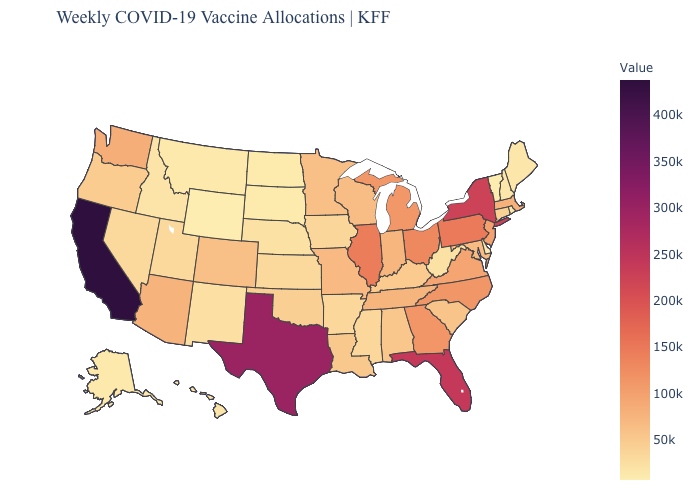Is the legend a continuous bar?
Short answer required. Yes. Does Alaska have the highest value in the West?
Quick response, please. No. Which states have the highest value in the USA?
Keep it brief. California. Which states have the lowest value in the Northeast?
Be succinct. Vermont. Does Wyoming have the lowest value in the USA?
Answer briefly. Yes. Which states hav the highest value in the Northeast?
Quick response, please. New York. Which states have the highest value in the USA?
Give a very brief answer. California. 